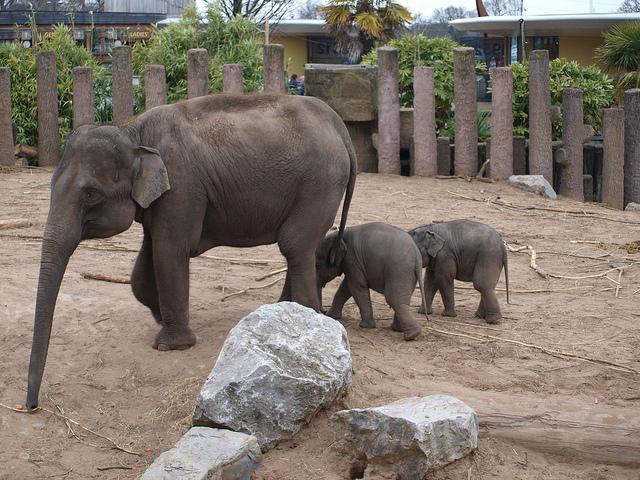Are these elephants following the adult elephant?
Answer briefly. Yes. How many elephants are in the picture?
Be succinct. 3. How many elephants are here?
Short answer required. 3. How many rocks are in the picture?
Keep it brief. 4. Do these animals appear to be in the wild?
Be succinct. No. How many baby elephants are in the picture?
Be succinct. 2. Does the rock in the foreground have a crack in it?
Keep it brief. No. 